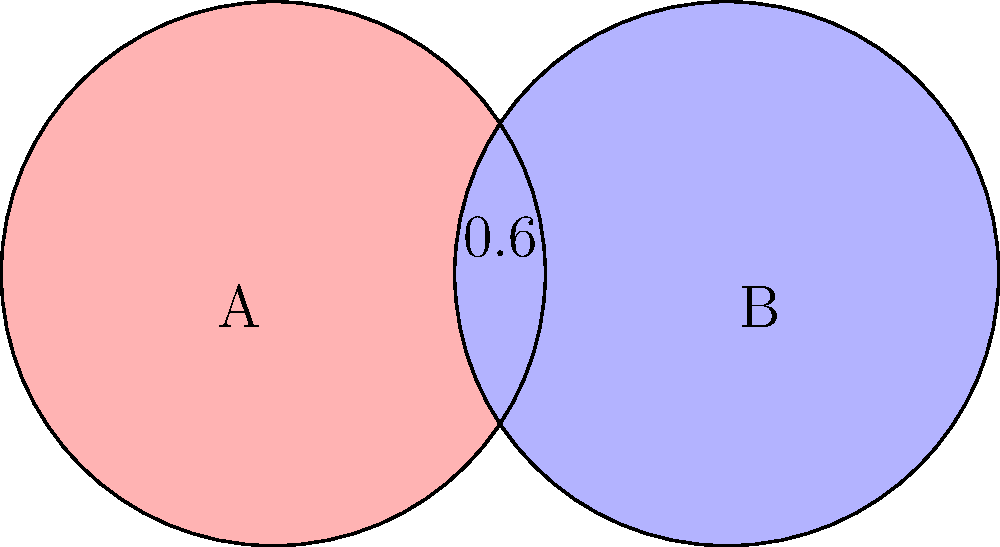In a mathematics textbook, two overlapping circles are used to represent a Venn diagram. Each circle has a radius of 0.6 units, and their centers are 1 unit apart. What is the area of the overlapping region (intersection) of these two circles? Round your answer to three decimal places. To find the area of the overlapping region, we'll follow these steps:

1) First, we need to find the angle θ at the center of each circle that forms the overlapping region:
   $$\cos(\theta/2) = \frac{0.5}{0.6} = \frac{5}{6}$$
   $$\theta = 2 \arccos(\frac{5}{6}) \approx 1.2870 \text{ radians}$$

2) The area of a sector with angle θ is:
   $$A_{sector} = \frac{1}{2} r^2 \theta$$
   $$A_{sector} = \frac{1}{2} (0.6)^2 (1.2870) \approx 0.2317 \text{ square units}$$

3) The area of the triangle formed by the radius and chord is:
   $$A_{triangle} = \frac{1}{2} (0.6 \cos(\theta/2))(0.6 \sin(\theta/2)) = \frac{1}{2} (0.5)(0.3) = 0.075 \text{ square units}$$

4) The area of the lens-shaped overlap is twice the difference between the sector and triangle:
   $$A_{overlap} = 2(A_{sector} - A_{triangle}) = 2(0.2317 - 0.075) \approx 0.3134 \text{ square units}$$

5) Rounding to three decimal places:
   $$A_{overlap} \approx 0.313 \text{ square units}$$
Answer: 0.313 square units 